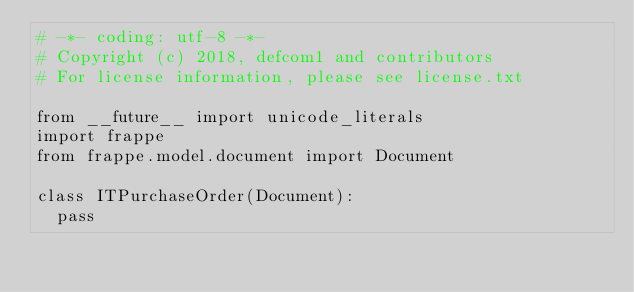Convert code to text. <code><loc_0><loc_0><loc_500><loc_500><_Python_># -*- coding: utf-8 -*-
# Copyright (c) 2018, defcom1 and contributors
# For license information, please see license.txt

from __future__ import unicode_literals
import frappe
from frappe.model.document import Document

class ITPurchaseOrder(Document):
	pass
</code> 